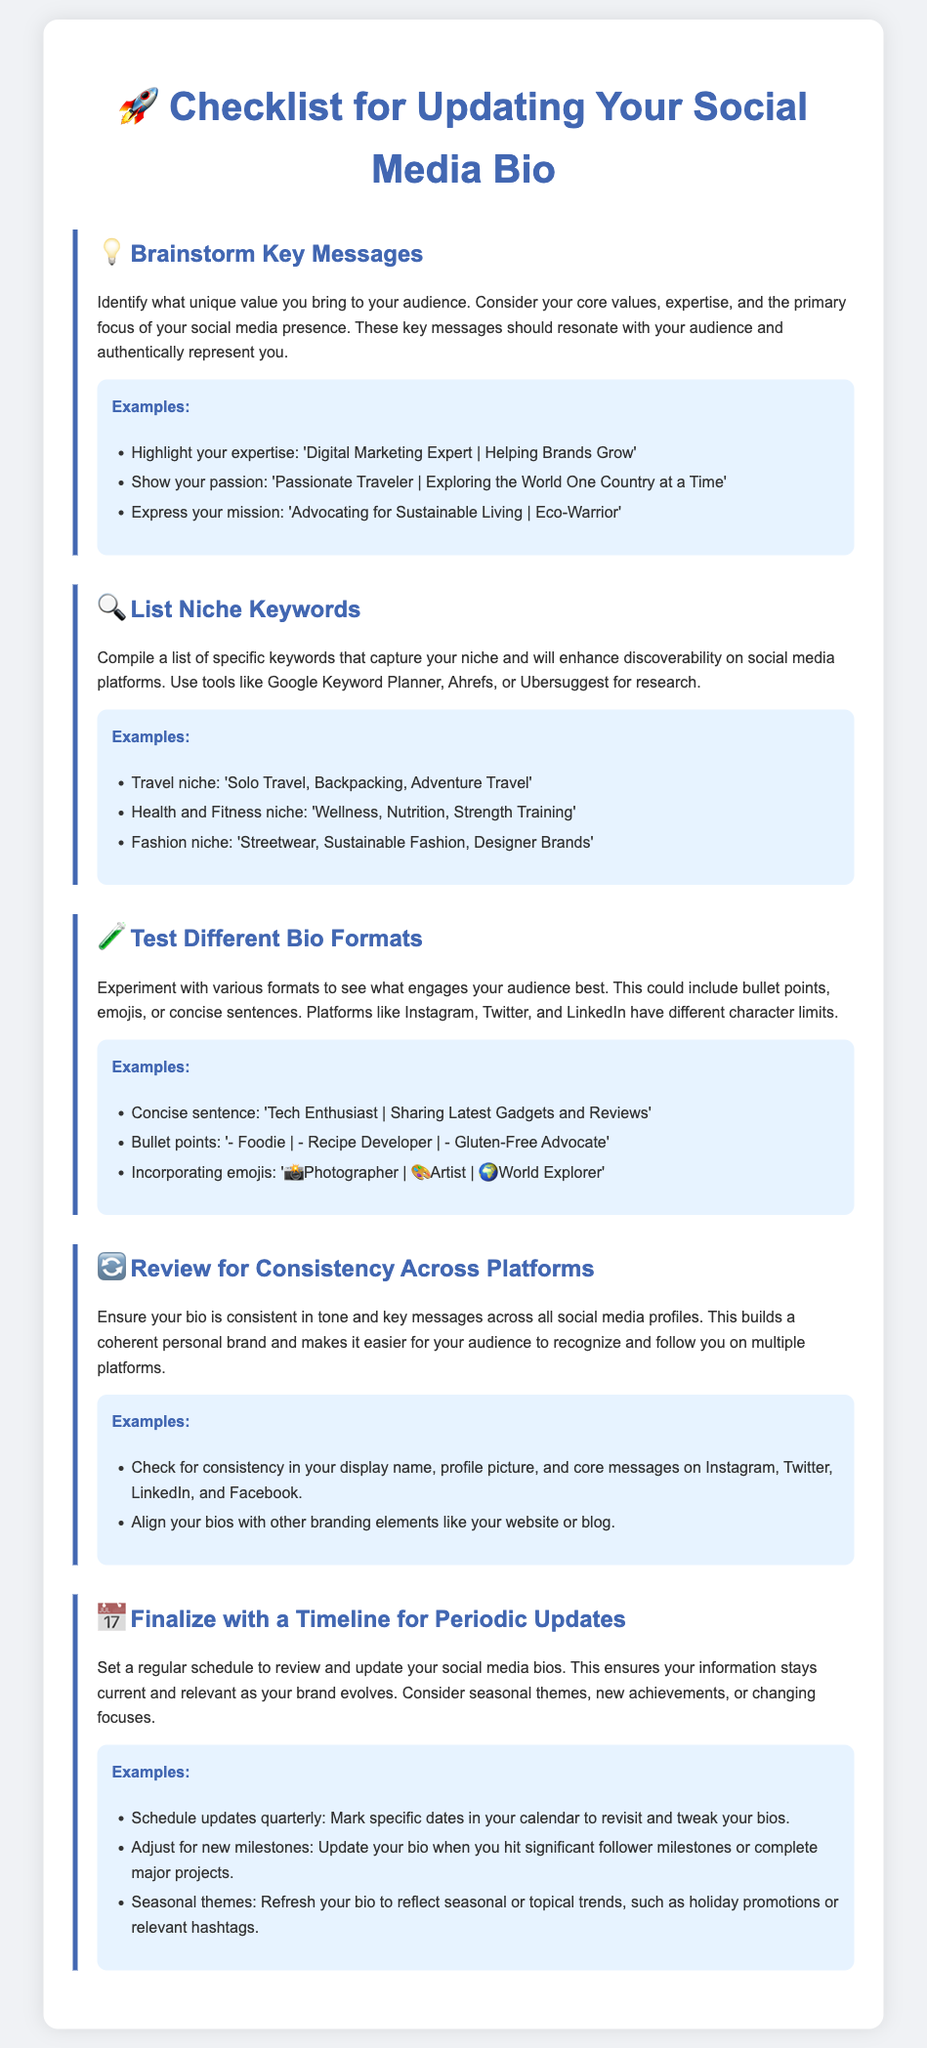What is the title of the document? The title of the document appears prominently at the top as a heading.
Answer: Checklist for Updating Your Social Media Bio What type of keywords should be listed according to the document? The document suggests types of keywords that cater to specific niches for enhancing discoverability.
Answer: Niche keywords What is the first step in the checklist? The first step is clearly labeled in the document and highlights the importance of crafting key messages.
Answer: Brainstorm Key Messages How often should social media bios be updated? The document indicates a frequency for reviewing and updating social media bios to keep them current.
Answer: Quarterly What format is suggested for testing different bio styles? The document mentions styles that can engage audiences effectively through specific formats.
Answer: Bullet points What emoji represents the step for reviewing consistency across platforms? Each step is accompanied by an emoji to enhance visual communication, including this specific one.
Answer: 🔄 Why is it important to have a consistent bio across platforms? The document discusses the significance of maintaining a coherent personal brand for audience recognition.
Answer: Builds a coherent personal brand What is one theme suggested for periodic bio updates? The document provides suggestions for themes to refresh bios, making them more relevant to the audience.
Answer: Seasonal themes 